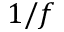Convert formula to latex. <formula><loc_0><loc_0><loc_500><loc_500>1 / f</formula> 